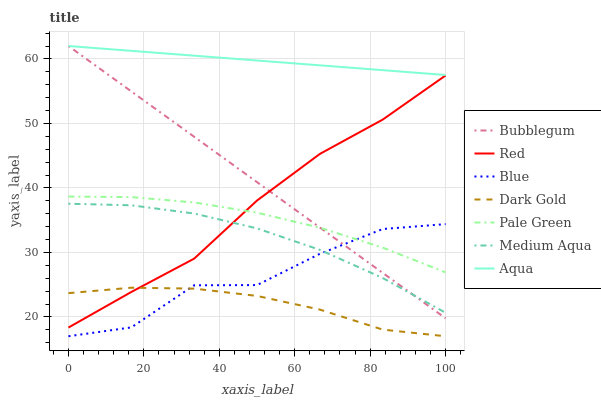Does Dark Gold have the minimum area under the curve?
Answer yes or no. Yes. Does Aqua have the maximum area under the curve?
Answer yes or no. Yes. Does Aqua have the minimum area under the curve?
Answer yes or no. No. Does Dark Gold have the maximum area under the curve?
Answer yes or no. No. Is Bubblegum the smoothest?
Answer yes or no. Yes. Is Blue the roughest?
Answer yes or no. Yes. Is Dark Gold the smoothest?
Answer yes or no. No. Is Dark Gold the roughest?
Answer yes or no. No. Does Blue have the lowest value?
Answer yes or no. Yes. Does Aqua have the lowest value?
Answer yes or no. No. Does Bubblegum have the highest value?
Answer yes or no. Yes. Does Dark Gold have the highest value?
Answer yes or no. No. Is Red less than Aqua?
Answer yes or no. Yes. Is Aqua greater than Red?
Answer yes or no. Yes. Does Bubblegum intersect Aqua?
Answer yes or no. Yes. Is Bubblegum less than Aqua?
Answer yes or no. No. Is Bubblegum greater than Aqua?
Answer yes or no. No. Does Red intersect Aqua?
Answer yes or no. No. 